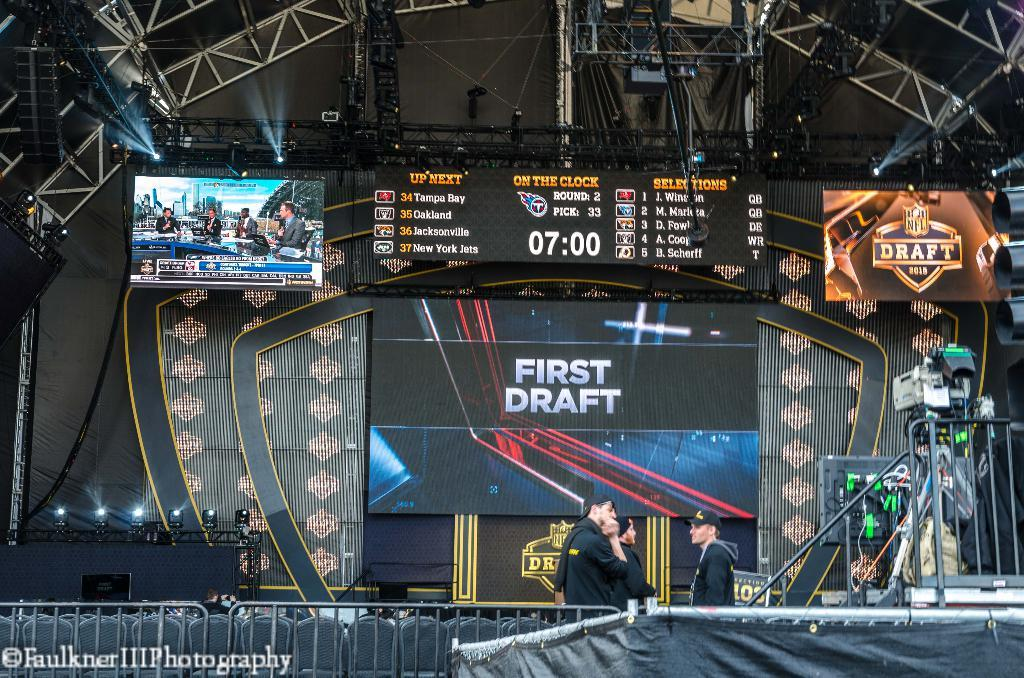Provide a one-sentence caption for the provided image. A stage for a fotball game with the words first draft in the center. 